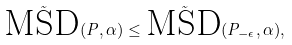Convert formula to latex. <formula><loc_0><loc_0><loc_500><loc_500>\tilde { \text {MSD} } ( P , \alpha ) \leq \tilde { \text {MSD} } ( P _ { - \epsilon } , \alpha ) ,</formula> 